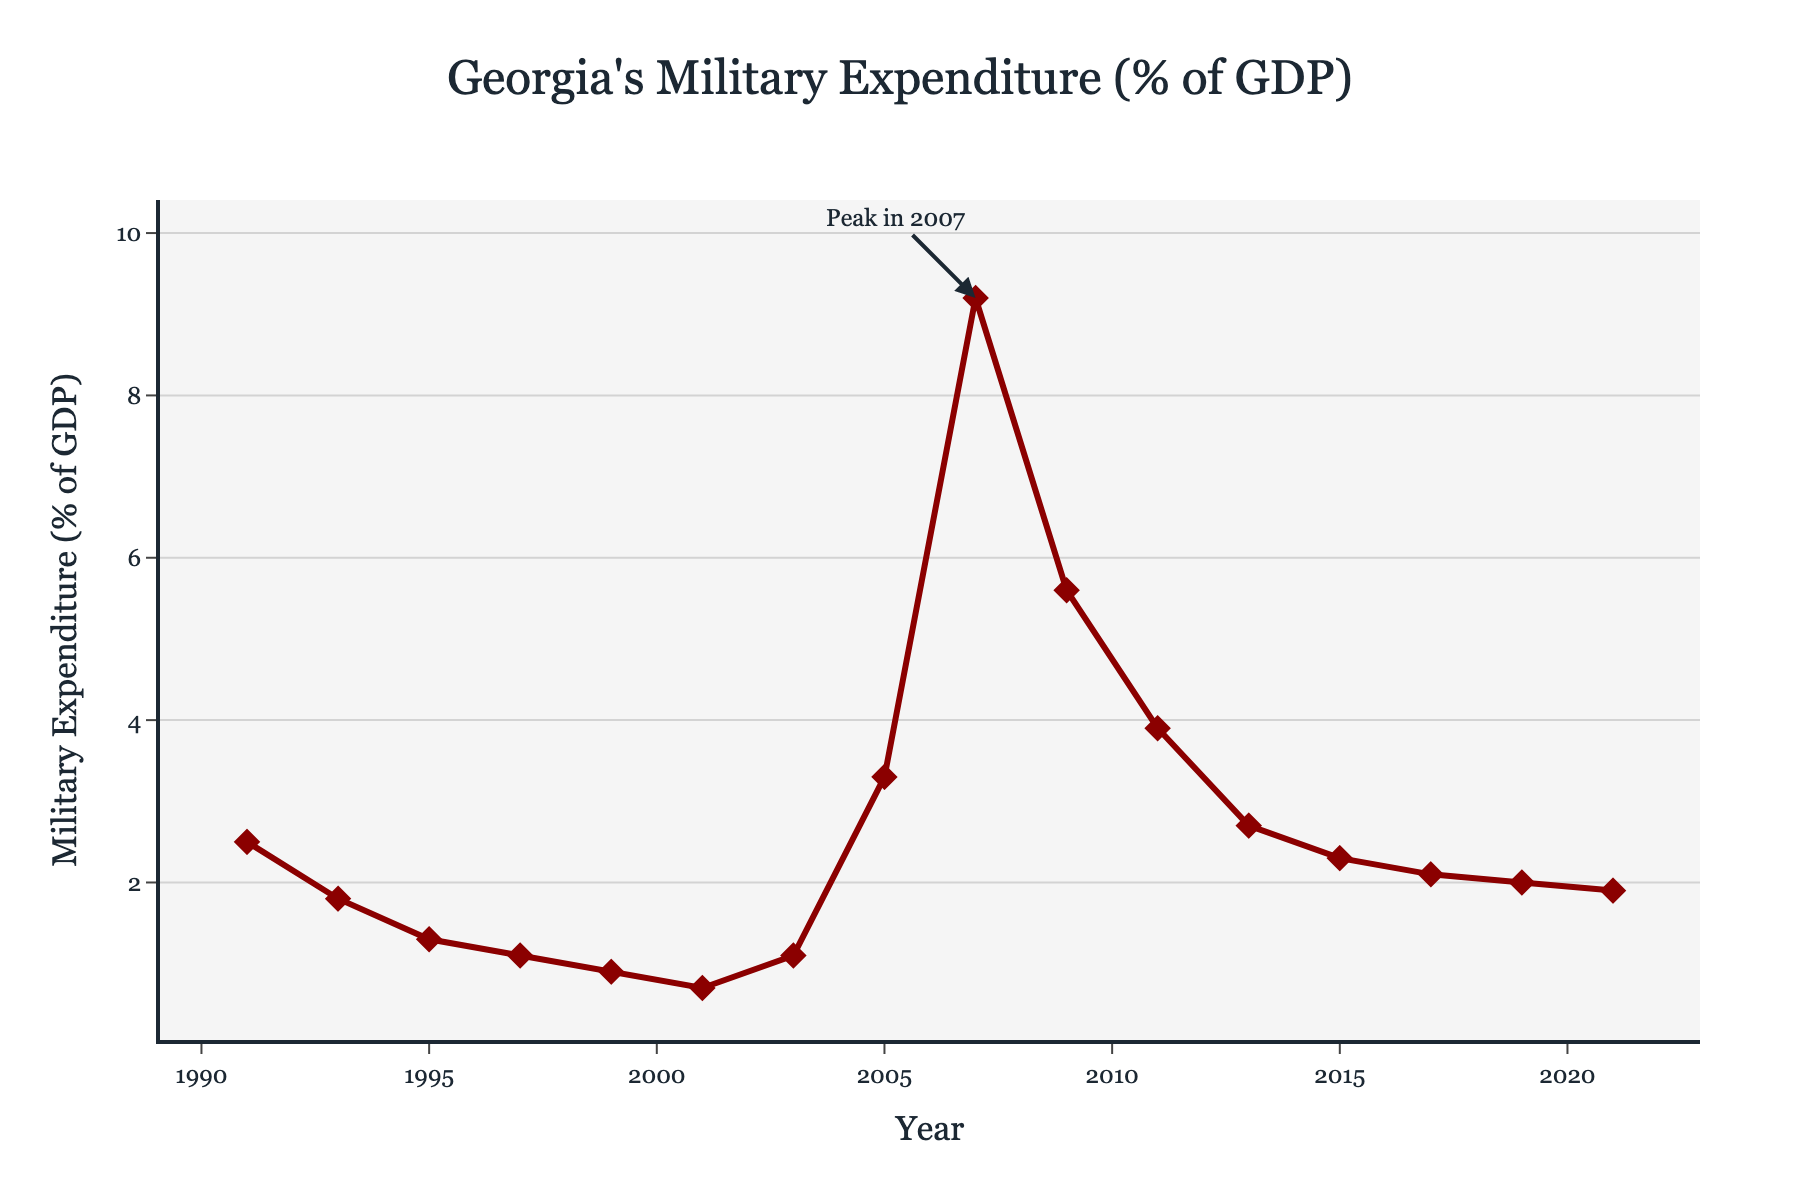what's the highest military expenditure percentage of GDP and in which year did it occur? The highest military expenditure percentage is represented by the peak on the graph, which is labeled "Peak in 2007". This peak has a value of 9.2%.
Answer: 9.2%, 2007 how did military expenditure change from 1991 to 1999? To determine the change, observe the endpoints of the period 1991 and 1999. In 1991, the expenditure was 2.5% of GDP, and it decreased to 0.9% by 1999. The change is 2.5% – 0.9% = 1.6%.
Answer: Decreased by 1.6% in which year did Georgia's military expenditure (% of GDP) first increase after 1991? Examine the data points after 1991 to identify the first year with an increase. In 1991, it was 2.5%, and the first increase occurs from 2001 (0.7%) to 2003 (1.1%).
Answer: 2003 which year had a military expenditure closest to 2% of GDP and what was the exact percentage? To find the year with military expenditure closest to 2%, observe the points near the 2% line. In 2019, the expenditure was 2.0%.
Answer: 2019, 2.0% calculate the average military expenditure (% of GDP) from 2011 to 2021 Average can be found by summing the values from 2011 (3.9%), 2013 (2.7%), 2015 (2.3%), 2017 (2.1%), 2019 (2.0%), and 2021 (1.9%), then dividing by the number of years. (3.9 + 2.7 + 2.3 + 2.1 + 2.0 + 1.9) / 6 = 2.48%
Answer: 2.48% compare the military expenditure in 1995 to that in 2005; which year had a higher percentage and by how much? In 1995, military expenditure was 1.3%, and in 2005, it was 3.3%. Subtracting the two gives 3.3% - 1.3% = 2.0%. Thus, 2005 had a higher percentage by 2.0%.
Answer: 2005, by 2.0% what trend can be observed between 1999 and 2007? Examine the trend between 1999 and 2007: in 1999, it was 0.9% and there was a peak at 9.2% in 2007. The trend is an increase.
Answer: Increasing trend how did the military expenditure change from 2007 to 2009? Observe the values at 2007 and 2009. In 2007, it was 9.2% and decreased to 5.6% in 2009. 9.2% - 5.6% = 3.6%.
Answer: Decreased by 3.6% how many years did Georgia experience a military expenditure percentage below 1% and what were those years? Identify the years with values below 1%. They are 1997 (1.1%), 1999 (0.9%), and 2001 (0.7%).
Answer: 3 years: 1997, 1999, 2001 which period saw the most significant increase in military expenditure (% of GDP)? Examine the slopes of the line segments. The most significant increase is from 2003 (1.1%) to 2007 (9.2%).
Answer: 2003-2007 